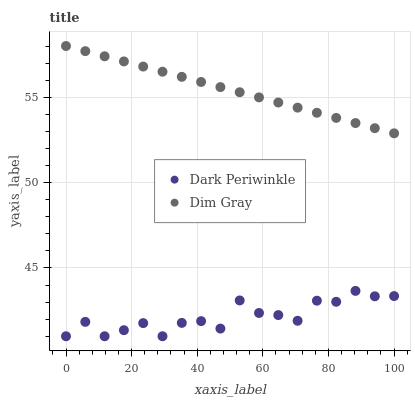Does Dark Periwinkle have the minimum area under the curve?
Answer yes or no. Yes. Does Dim Gray have the maximum area under the curve?
Answer yes or no. Yes. Does Dark Periwinkle have the maximum area under the curve?
Answer yes or no. No. Is Dim Gray the smoothest?
Answer yes or no. Yes. Is Dark Periwinkle the roughest?
Answer yes or no. Yes. Is Dark Periwinkle the smoothest?
Answer yes or no. No. Does Dark Periwinkle have the lowest value?
Answer yes or no. Yes. Does Dim Gray have the highest value?
Answer yes or no. Yes. Does Dark Periwinkle have the highest value?
Answer yes or no. No. Is Dark Periwinkle less than Dim Gray?
Answer yes or no. Yes. Is Dim Gray greater than Dark Periwinkle?
Answer yes or no. Yes. Does Dark Periwinkle intersect Dim Gray?
Answer yes or no. No. 